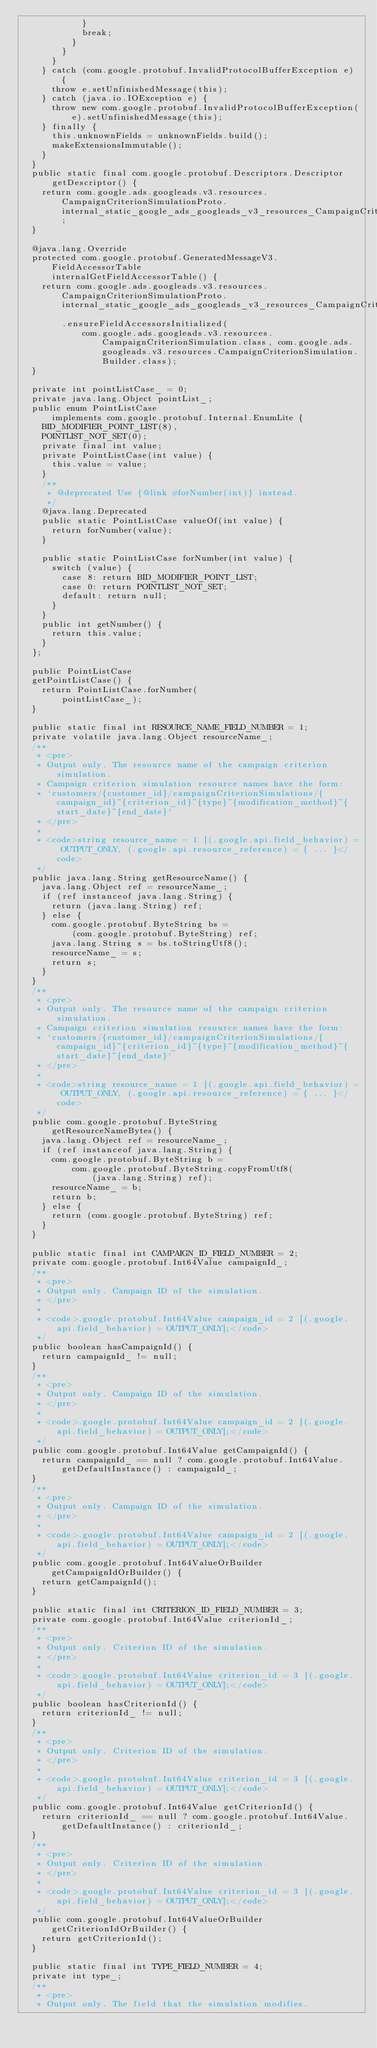Convert code to text. <code><loc_0><loc_0><loc_500><loc_500><_Java_>            }
            break;
          }
        }
      }
    } catch (com.google.protobuf.InvalidProtocolBufferException e) {
      throw e.setUnfinishedMessage(this);
    } catch (java.io.IOException e) {
      throw new com.google.protobuf.InvalidProtocolBufferException(
          e).setUnfinishedMessage(this);
    } finally {
      this.unknownFields = unknownFields.build();
      makeExtensionsImmutable();
    }
  }
  public static final com.google.protobuf.Descriptors.Descriptor
      getDescriptor() {
    return com.google.ads.googleads.v3.resources.CampaignCriterionSimulationProto.internal_static_google_ads_googleads_v3_resources_CampaignCriterionSimulation_descriptor;
  }

  @java.lang.Override
  protected com.google.protobuf.GeneratedMessageV3.FieldAccessorTable
      internalGetFieldAccessorTable() {
    return com.google.ads.googleads.v3.resources.CampaignCriterionSimulationProto.internal_static_google_ads_googleads_v3_resources_CampaignCriterionSimulation_fieldAccessorTable
        .ensureFieldAccessorsInitialized(
            com.google.ads.googleads.v3.resources.CampaignCriterionSimulation.class, com.google.ads.googleads.v3.resources.CampaignCriterionSimulation.Builder.class);
  }

  private int pointListCase_ = 0;
  private java.lang.Object pointList_;
  public enum PointListCase
      implements com.google.protobuf.Internal.EnumLite {
    BID_MODIFIER_POINT_LIST(8),
    POINTLIST_NOT_SET(0);
    private final int value;
    private PointListCase(int value) {
      this.value = value;
    }
    /**
     * @deprecated Use {@link #forNumber(int)} instead.
     */
    @java.lang.Deprecated
    public static PointListCase valueOf(int value) {
      return forNumber(value);
    }

    public static PointListCase forNumber(int value) {
      switch (value) {
        case 8: return BID_MODIFIER_POINT_LIST;
        case 0: return POINTLIST_NOT_SET;
        default: return null;
      }
    }
    public int getNumber() {
      return this.value;
    }
  };

  public PointListCase
  getPointListCase() {
    return PointListCase.forNumber(
        pointListCase_);
  }

  public static final int RESOURCE_NAME_FIELD_NUMBER = 1;
  private volatile java.lang.Object resourceName_;
  /**
   * <pre>
   * Output only. The resource name of the campaign criterion simulation.
   * Campaign criterion simulation resource names have the form:
   * `customers/{customer_id}/campaignCriterionSimulations/{campaign_id}~{criterion_id}~{type}~{modification_method}~{start_date}~{end_date}`
   * </pre>
   *
   * <code>string resource_name = 1 [(.google.api.field_behavior) = OUTPUT_ONLY, (.google.api.resource_reference) = { ... }</code>
   */
  public java.lang.String getResourceName() {
    java.lang.Object ref = resourceName_;
    if (ref instanceof java.lang.String) {
      return (java.lang.String) ref;
    } else {
      com.google.protobuf.ByteString bs = 
          (com.google.protobuf.ByteString) ref;
      java.lang.String s = bs.toStringUtf8();
      resourceName_ = s;
      return s;
    }
  }
  /**
   * <pre>
   * Output only. The resource name of the campaign criterion simulation.
   * Campaign criterion simulation resource names have the form:
   * `customers/{customer_id}/campaignCriterionSimulations/{campaign_id}~{criterion_id}~{type}~{modification_method}~{start_date}~{end_date}`
   * </pre>
   *
   * <code>string resource_name = 1 [(.google.api.field_behavior) = OUTPUT_ONLY, (.google.api.resource_reference) = { ... }</code>
   */
  public com.google.protobuf.ByteString
      getResourceNameBytes() {
    java.lang.Object ref = resourceName_;
    if (ref instanceof java.lang.String) {
      com.google.protobuf.ByteString b = 
          com.google.protobuf.ByteString.copyFromUtf8(
              (java.lang.String) ref);
      resourceName_ = b;
      return b;
    } else {
      return (com.google.protobuf.ByteString) ref;
    }
  }

  public static final int CAMPAIGN_ID_FIELD_NUMBER = 2;
  private com.google.protobuf.Int64Value campaignId_;
  /**
   * <pre>
   * Output only. Campaign ID of the simulation.
   * </pre>
   *
   * <code>.google.protobuf.Int64Value campaign_id = 2 [(.google.api.field_behavior) = OUTPUT_ONLY];</code>
   */
  public boolean hasCampaignId() {
    return campaignId_ != null;
  }
  /**
   * <pre>
   * Output only. Campaign ID of the simulation.
   * </pre>
   *
   * <code>.google.protobuf.Int64Value campaign_id = 2 [(.google.api.field_behavior) = OUTPUT_ONLY];</code>
   */
  public com.google.protobuf.Int64Value getCampaignId() {
    return campaignId_ == null ? com.google.protobuf.Int64Value.getDefaultInstance() : campaignId_;
  }
  /**
   * <pre>
   * Output only. Campaign ID of the simulation.
   * </pre>
   *
   * <code>.google.protobuf.Int64Value campaign_id = 2 [(.google.api.field_behavior) = OUTPUT_ONLY];</code>
   */
  public com.google.protobuf.Int64ValueOrBuilder getCampaignIdOrBuilder() {
    return getCampaignId();
  }

  public static final int CRITERION_ID_FIELD_NUMBER = 3;
  private com.google.protobuf.Int64Value criterionId_;
  /**
   * <pre>
   * Output only. Criterion ID of the simulation.
   * </pre>
   *
   * <code>.google.protobuf.Int64Value criterion_id = 3 [(.google.api.field_behavior) = OUTPUT_ONLY];</code>
   */
  public boolean hasCriterionId() {
    return criterionId_ != null;
  }
  /**
   * <pre>
   * Output only. Criterion ID of the simulation.
   * </pre>
   *
   * <code>.google.protobuf.Int64Value criterion_id = 3 [(.google.api.field_behavior) = OUTPUT_ONLY];</code>
   */
  public com.google.protobuf.Int64Value getCriterionId() {
    return criterionId_ == null ? com.google.protobuf.Int64Value.getDefaultInstance() : criterionId_;
  }
  /**
   * <pre>
   * Output only. Criterion ID of the simulation.
   * </pre>
   *
   * <code>.google.protobuf.Int64Value criterion_id = 3 [(.google.api.field_behavior) = OUTPUT_ONLY];</code>
   */
  public com.google.protobuf.Int64ValueOrBuilder getCriterionIdOrBuilder() {
    return getCriterionId();
  }

  public static final int TYPE_FIELD_NUMBER = 4;
  private int type_;
  /**
   * <pre>
   * Output only. The field that the simulation modifies.</code> 